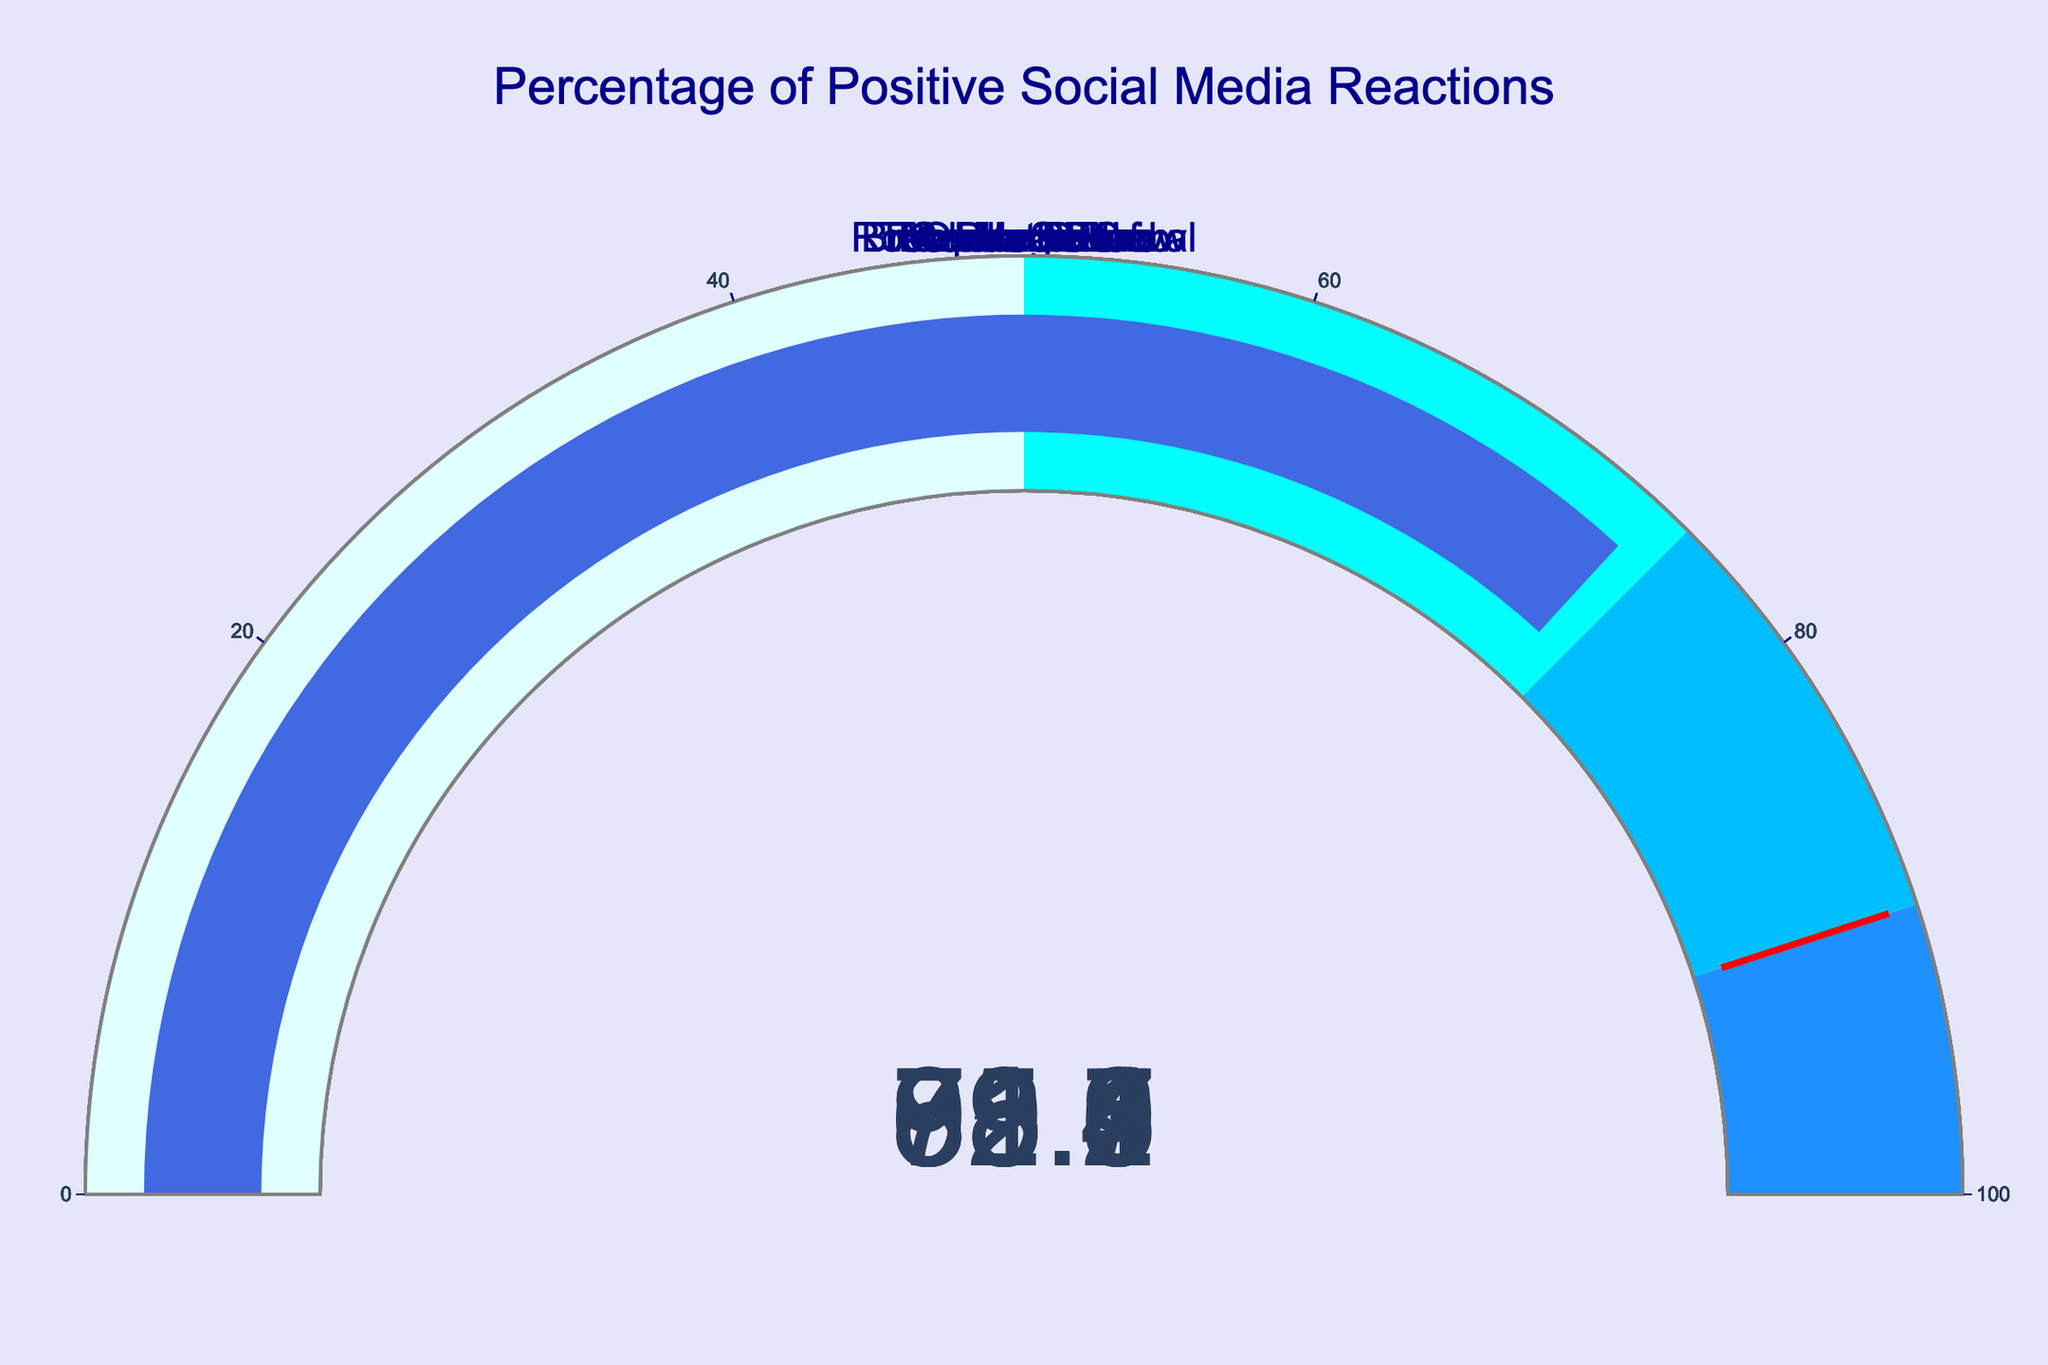What is the title of the figure? The title of the figure is prominently displayed at the top of the chart, and it reads "Percentage of Positive Social Media Reactions."
Answer: Percentage of Positive Social Media Reactions How many contestants are displayed in the figure? Each gauge represents a different contestant, and by counting the number of gauges, we can determine the number of contestants. There are eight gauges, each labeled with a different contestant's name.
Answer: 8 Which contestant received the highest percentage of positive social media reactions? By observing the gauges, we look for the one with the highest value. The gauge for Teen Heartthrob shows 95.2%, which is the highest value among all the contestants.
Answer: Teen Heartthrob What is the approximate average percentage of positive reactions for all contestants? To find the average, we sum all the percentages and then divide by the number of contestants. Summing the values: 92.5 + 78.3 + 85.7 + 69.4 + 88.1 + 81.9 + 95.2 + 73.6 = 665.7. Dividing by 8 (number of contestants): 665.7 / 8 ≈ 83.21.
Answer: 83.21 Which contestants' reaction percentages fall within the range of 75% to 90%? We look at each gauge to see which values fall between 75 and 90. The contestants are The Magicians (78.3), Breakdance Crew (85.7), Acrobatic Duo (81.9), and Adele Smith (92.5 but over threshold), so remove Adele Smith.
Answer: The Magicians, Breakdance Crew, Acrobatic Duo What is the difference in positive reaction percentages between the contestant with the highest and the one with the lowest values? Teen Heartthrob has the highest at 95.2%, and Opera Diva has the lowest at 69.4%. The difference is found by subtracting the lowest from the highest: 95.2 - 69.4 = 25.8.
Answer: 25.8 Which contestant is closest to the threshold value set at 90%? We look for the gauge that is nearest to but not necessarily above the threshold. Adele Smith, with a positive reaction percentage of 92.5%, is the closest to the threshold value of 90%.
Answer: Adele Smith Are there more contestants above or below the threshold of 75%? We count the gauges above 75% and below 75%. Above: Adele Smith (92.5), The Magicians (78.3), Breakdance Crew (85.7), Comic Relief (88.1), Acrobatic Duo (81.9), Teen Heartthrob (95.2), Rock Band Revival (73.6) - Total 6. Below: Opera Diva (69.4).
Answer: Above Is there a contestant whose gauge value falls exactly in the middle range step of the gauge chart (50-75%)? The gauge chart shows mid-range steps for 50-75% which represent values falling in that specific interval. Checking each gauge, The Magicians' gauge reads 78.3%, which does not fit into 50-75%. Only Rock Band Revival (73.6%) falls into that range.
Answer: Rock Band Revival 